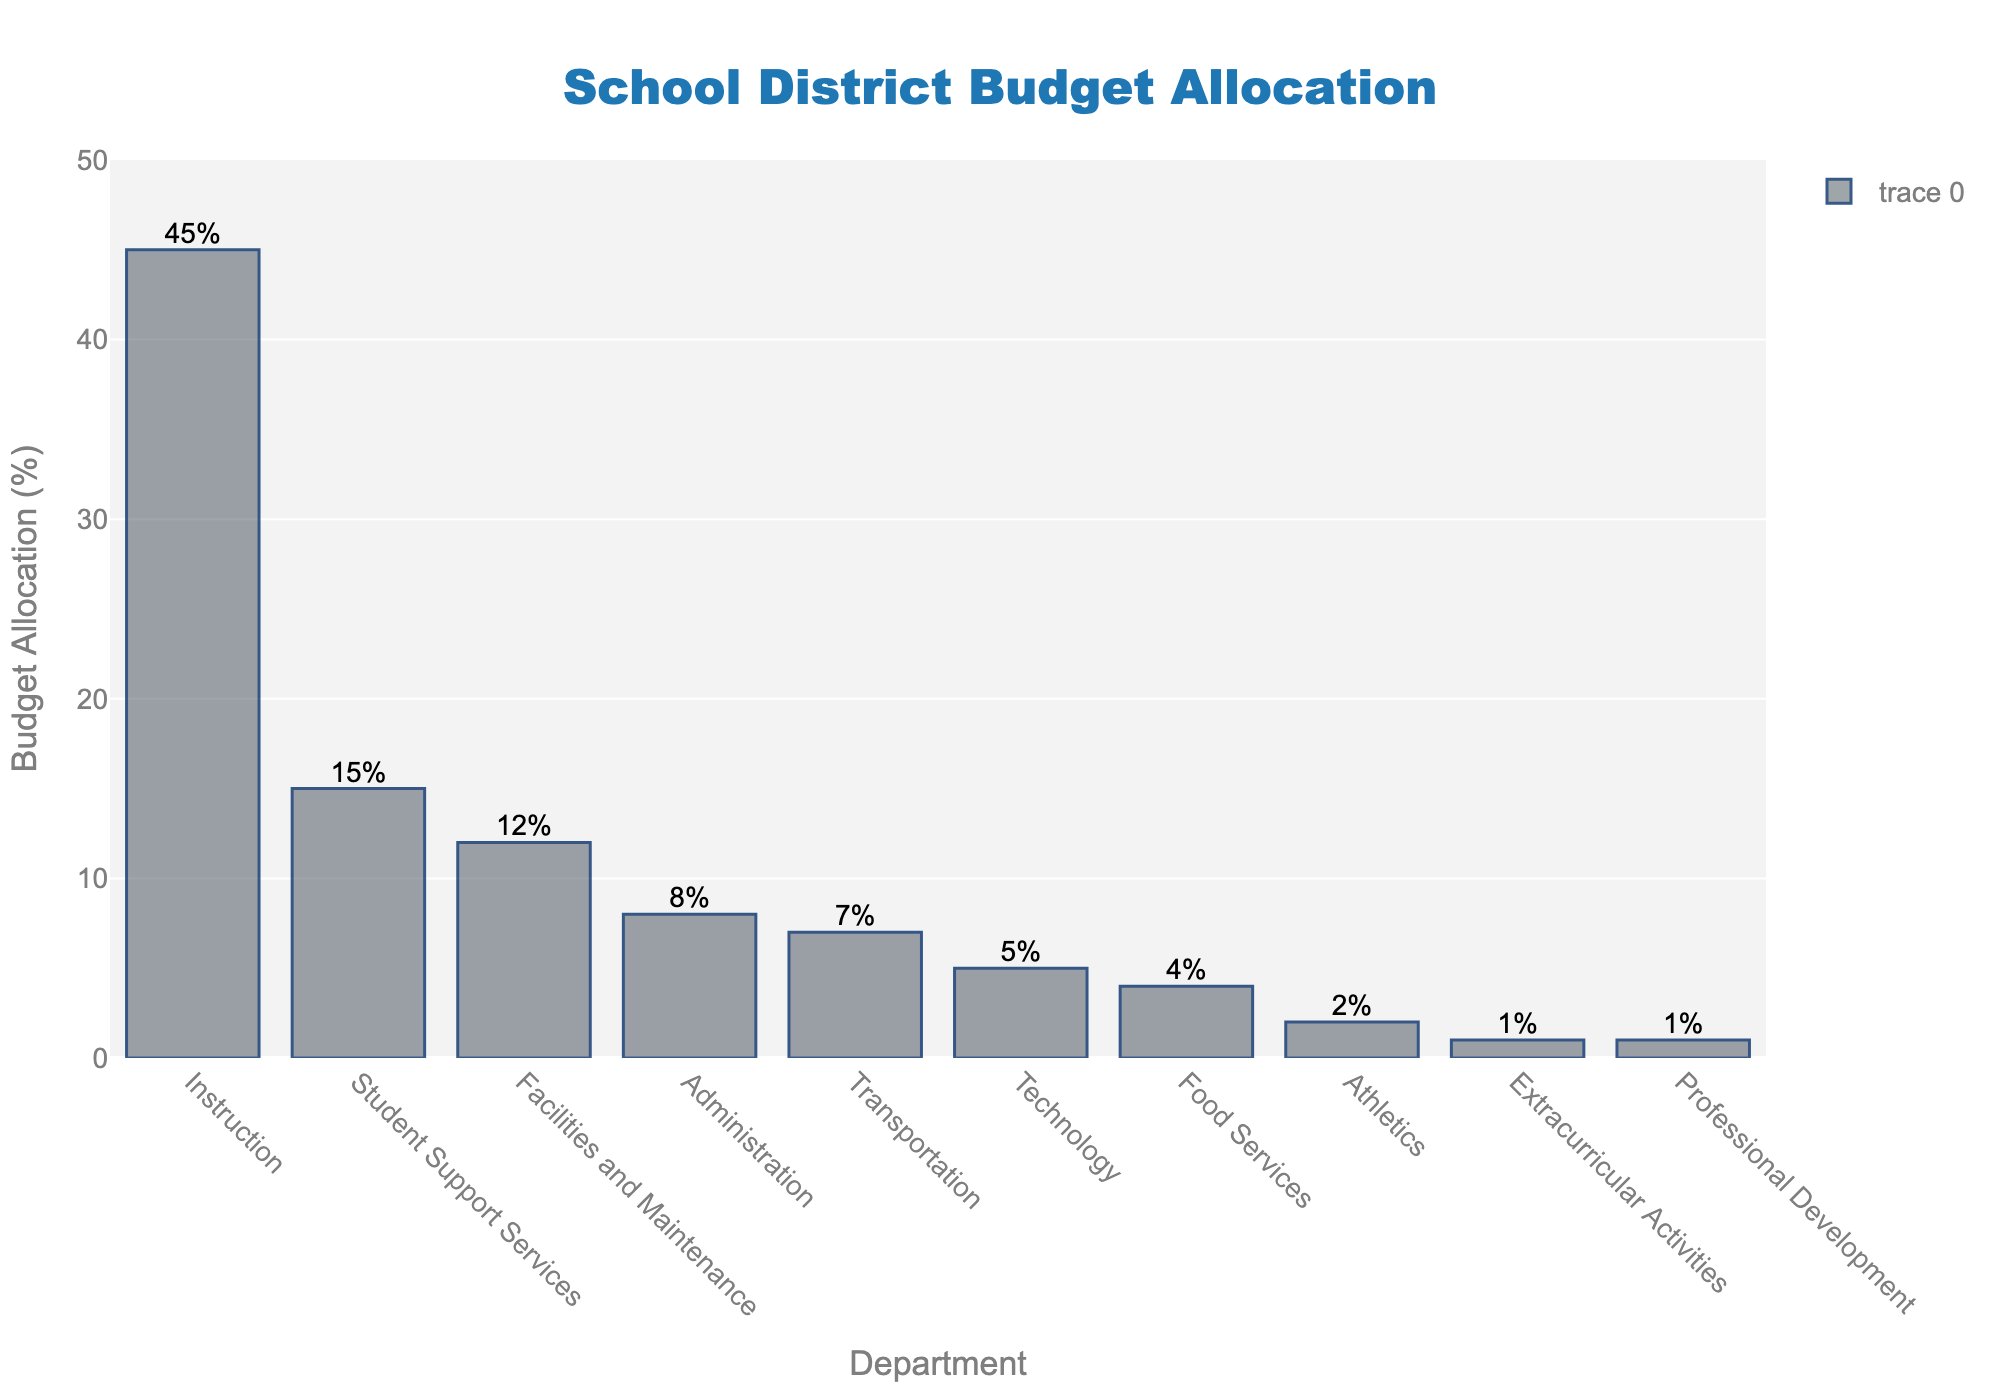How much budget is allocated to Instruction and Administration combined? The figure shows that Instruction has 45% and Administration has 8%. Adding these allocations together: 45% + 8% = 53%.
Answer: 53% Which department receives the lowest budget allocation? According to the bar heights and labels in the figure, Extracurricular Activities and Professional Development each receive 1%. Hence, they are the lowest.
Answer: Extracurricular Activities and Professional Development What is the difference in budget allocation between Facilities and Maintenance and Technology? The figure indicates Facilities and Maintenance receive 12%, while Technology receives 5%. Subtracting the two: 12% - 5% = 7%.
Answer: 7% Is the allocation to Transportation greater than to Food Services? The figure shows that Transportation receives 7% and Food Services receives 4%. Since 7% is greater than 4%, Transportation's allocation is indeed greater.
Answer: Yes What is the average budget allocation across all departments? First, sum the allocations: 45 + 15 + 12 + 8 + 7 + 5 + 4 + 2 + 1 + 1 = 100. Then, since there are 10 departments, the average is 100/10 = 10%.
Answer: 10% Which department has the third highest budget allocation and what is its value? The top three departments by budget allocation are sorted as follows: Instruction (45%), Student Support Services (15%), and Facilities and Maintenance (12%), so Facilities and Maintenance is third with 12%.
Answer: Facilities and Maintenance, 12% What percentage of the budget is allocated to departments involved with student well-being (Student Support Services and Food Services combined)? The figure shows Student Support Services receive 15% and Food Services receive 4%. Summing these: 15% + 4% = 19%.
Answer: 19% How does the budget allocation for Athletics compare to that for Transportation? The figure shows Athletics receives 2% and Transportation receives 7%. Since 2% is less than 7%, Athletics receives a smaller portion of the budget.
Answer: Athletics receives less By how much is the budget allocation for Instruction greater than that for Technology? Instruction has 45% allocation and Technology has 5%. The difference is 45% - 5% = 40%.
Answer: 40% 